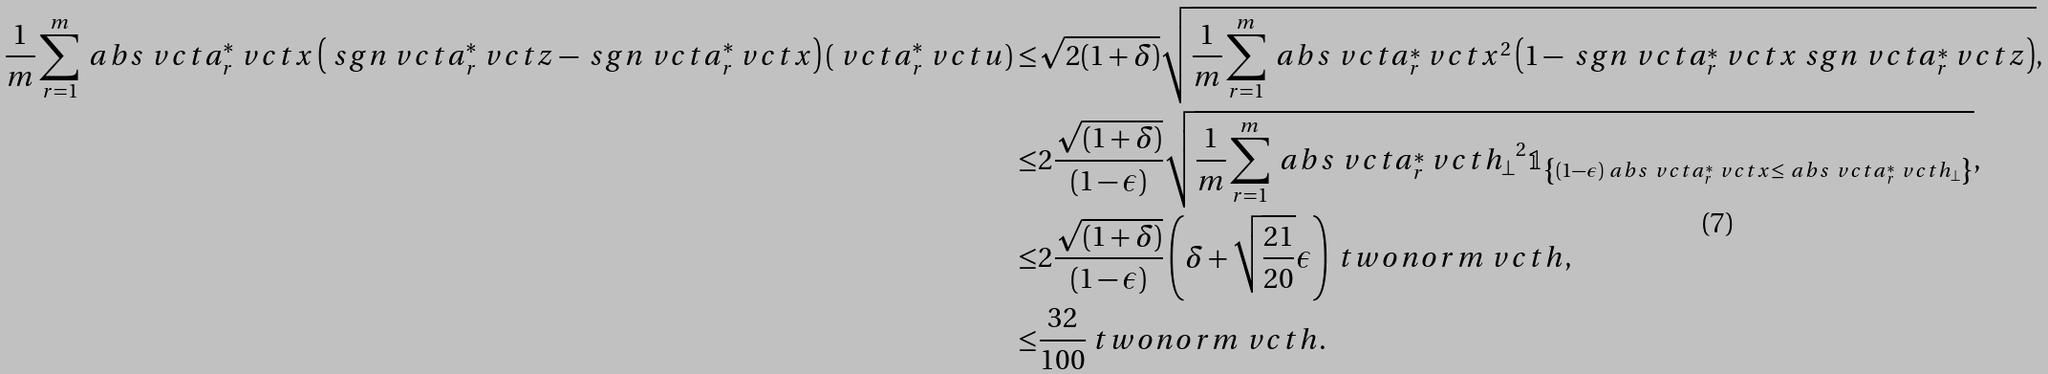Convert formula to latex. <formula><loc_0><loc_0><loc_500><loc_500>\frac { 1 } { m } \sum _ { r = 1 } ^ { m } \ a b s { \ v c t { a } _ { r } ^ { * } \ v c t { x } } \left ( \ s g n { \ v c t { a } _ { r } ^ { * } \ v c t { z } } - \ s g n { \ v c t { a } _ { r } ^ { * } \ v c t { x } } \right ) ( \ v c t { a } _ { r } ^ { * } \ v c t { u } ) \leq & \sqrt { 2 ( 1 + \delta ) } \sqrt { \frac { 1 } { m } \sum _ { r = 1 } ^ { m } \ a b s { \ v c t { a } _ { r } ^ { * } \ v c t { x } } ^ { 2 } \left ( 1 - \ s g n { \ v c t { a } _ { r } ^ { * } \ v c t { x } } \ s g n { \ v c t { a } _ { r } ^ { * } \ v c t { z } } \right ) } , \\ \leq & 2 \frac { \sqrt { ( 1 + \delta ) } } { ( 1 - \epsilon ) } \sqrt { \frac { 1 } { m } \sum _ { r = 1 } ^ { m } \ a b s { \ v c t { a } _ { r } ^ { * } \ v c t { h } _ { \perp } } ^ { 2 } \mathbb { 1 } _ { \left \{ ( 1 - \epsilon ) \ a b s { \ v c t { a } _ { r } ^ { * } \ v c t { x } } \leq \ a b s { \ v c t { a } _ { r } ^ { * } \ v c t { h } _ { \perp } } \right \} } } , \\ \leq & 2 \frac { \sqrt { ( 1 + \delta ) } } { ( 1 - \epsilon ) } \left ( \delta + \sqrt { \frac { 2 1 } { 2 0 } } \epsilon \right ) \ t w o n o r m { \ v c t { h } } , \\ \leq & \frac { 3 2 } { 1 0 0 } \ t w o n o r m { \ v c t { h } } .</formula> 